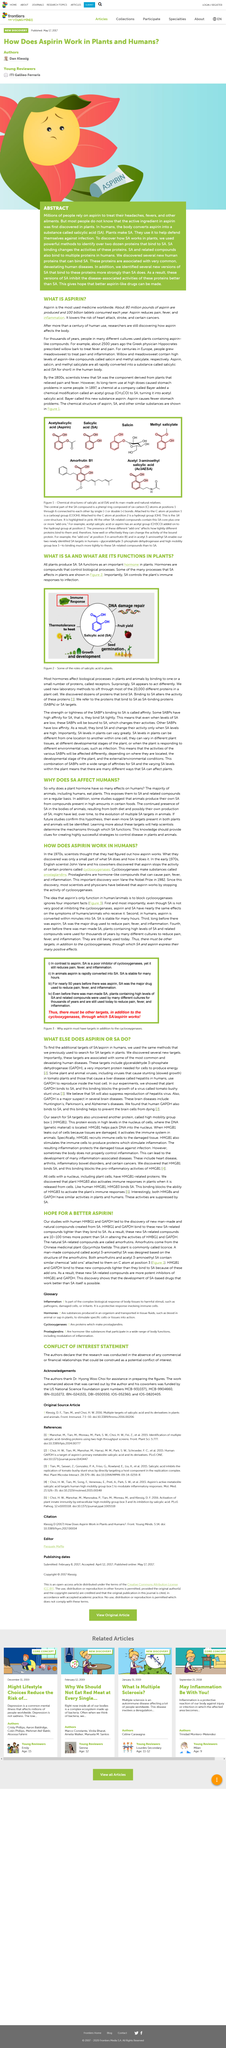Indicate a few pertinent items in this graphic. Aspirin inhibits the activity of cyclooxygenases proteins in humans. Aspirin can be used to alleviate pain, reduce fever, and mitigate inflammation, as stated in the aforementioned article. John Vane is from England. John Vane was awarded the Nobel Prize in Physiology or Medicine for his discovery that cyclooxygenases produce prostaglandins. The Greek physician Hippocrates prescribed willow bark to treat fever and pain about 2500 years ago. 